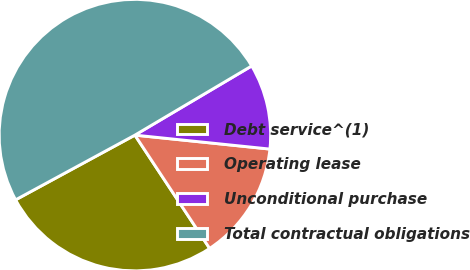Convert chart. <chart><loc_0><loc_0><loc_500><loc_500><pie_chart><fcel>Debt service^(1)<fcel>Operating lease<fcel>Unconditional purchase<fcel>Total contractual obligations<nl><fcel>26.37%<fcel>14.08%<fcel>10.15%<fcel>49.4%<nl></chart> 